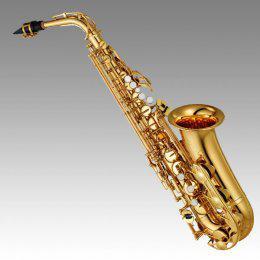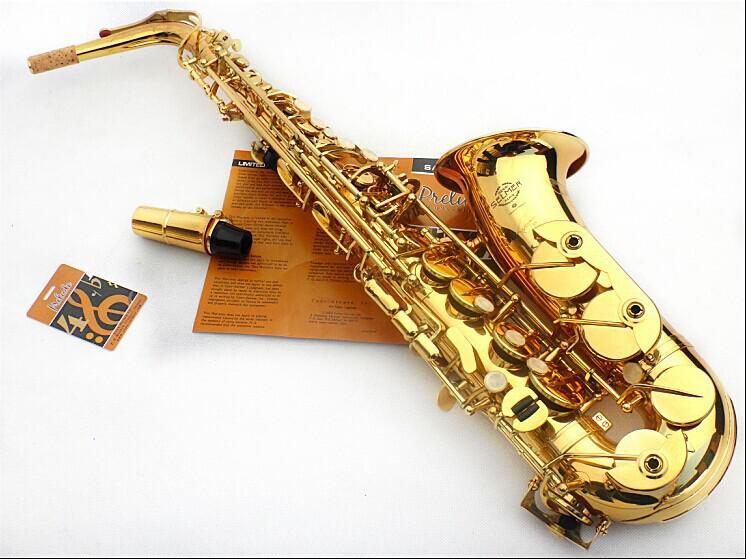The first image is the image on the left, the second image is the image on the right. For the images shown, is this caption "At least one of the images shows a booklet next to the instrument." true? Answer yes or no. Yes. The first image is the image on the left, the second image is the image on the right. For the images displayed, is the sentence "A mouthpiece with a black tip is next to a gold-colored saxophone in one image." factually correct? Answer yes or no. Yes. 